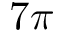<formula> <loc_0><loc_0><loc_500><loc_500>7 \pi</formula> 